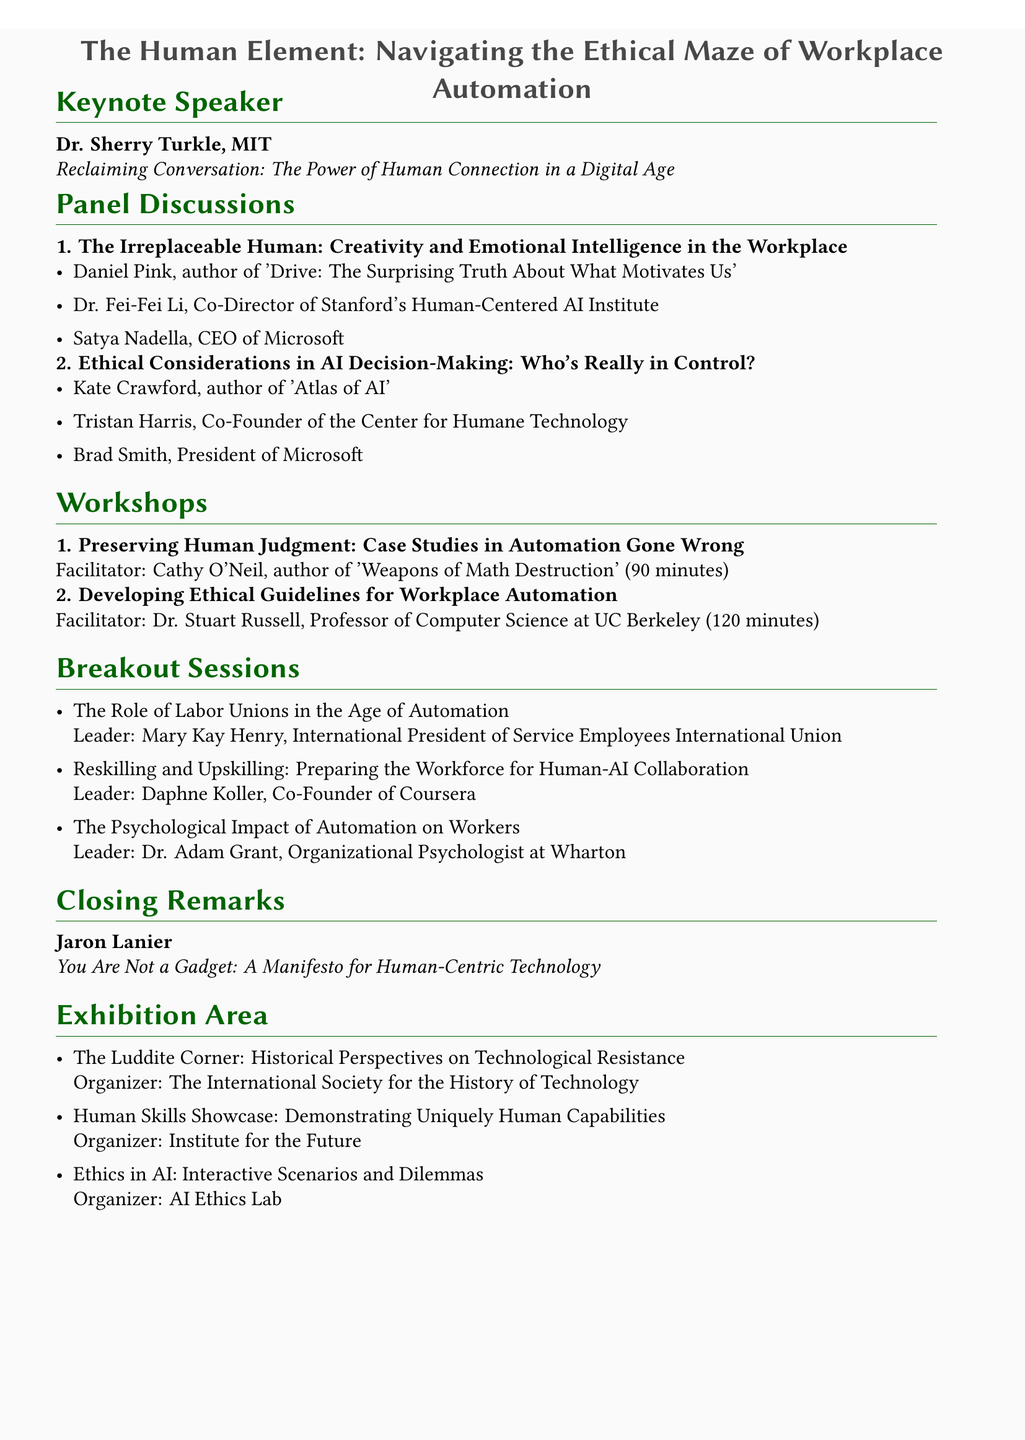What is the title of the seminar? The title of the seminar is provided as the main heading in the document.
Answer: The Human Element: Navigating the Ethical Maze of Workplace Automation Who is the keynote speaker? The document lists the keynote speaker under the respective section about the speaker.
Answer: Dr. Sherry Turkle How long is the workshop on "Developing Ethical Guidelines for Workplace Automation"? The duration of the workshop is stated alongside the workshop title in the document.
Answer: 120 minutes What is the main topic of the closing remarks? The topic of the closing remarks is specified in the section about the closing remarks.
Answer: You Are Not a Gadget: A Manifesto for Human-Centric Technology Who is leading the session on "The Psychological Impact of Automation on Workers"? The leader's name is mentioned next to the breakout session topic in the document.
Answer: Dr. Adam Grant How many panel discussions are listed in the document? The total number of panel discussions can be counted from the specified section in the document.
Answer: 2 Which organization is responsible for the booth named "The Luddite Corner"? The organizer for this specific booth is stated in the exhibition area section.
Answer: The International Society for the History of Technology What is the duration of the workshop on "Preserving Human Judgment: Case Studies in Automation Gone Wrong"? The duration for this workshop is provided directly after its title in the document.
Answer: 90 minutes 